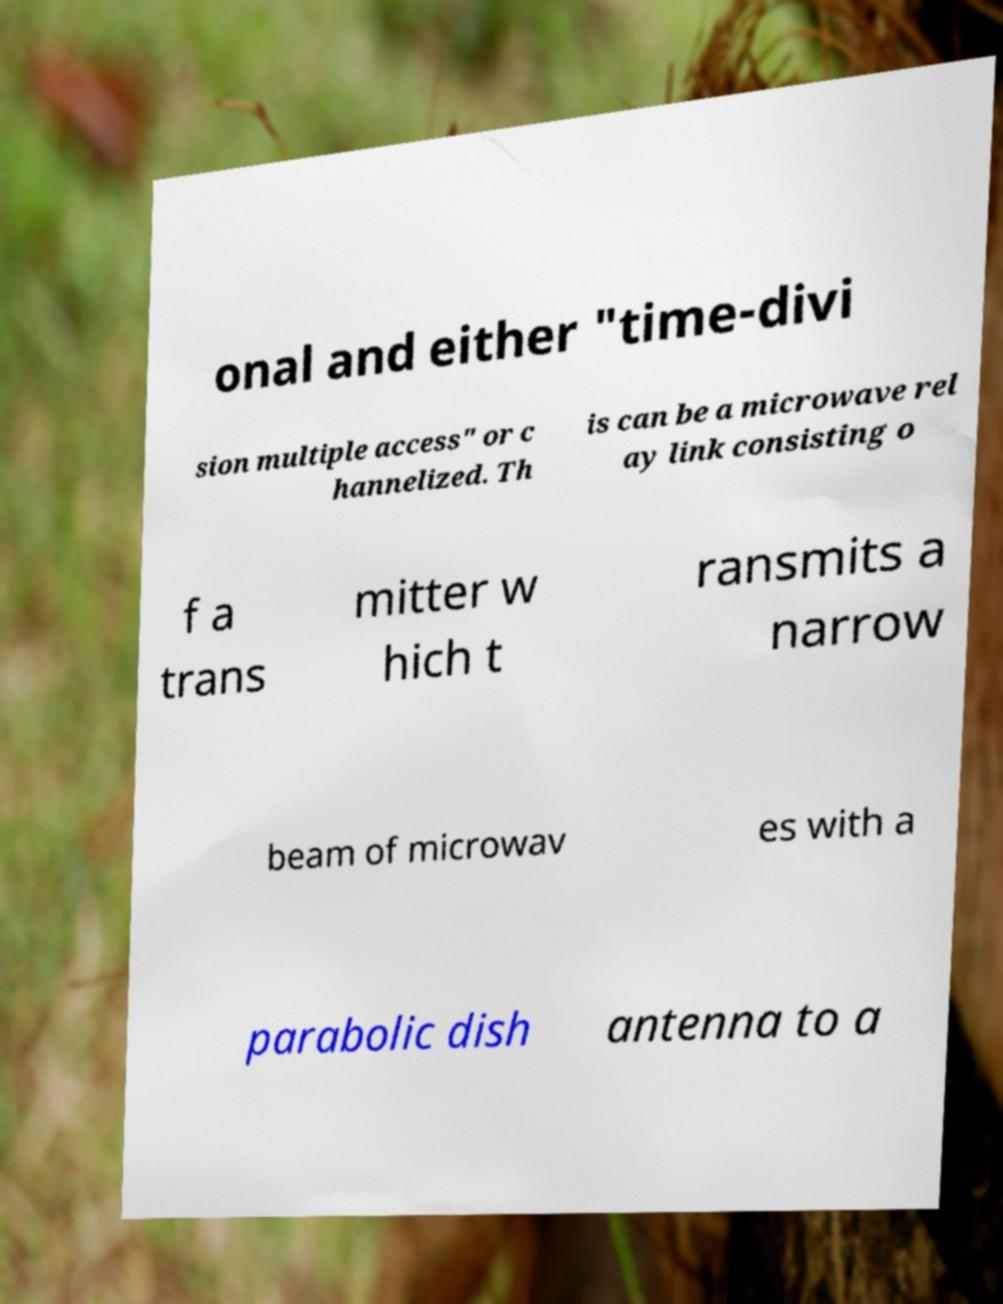There's text embedded in this image that I need extracted. Can you transcribe it verbatim? onal and either "time-divi sion multiple access" or c hannelized. Th is can be a microwave rel ay link consisting o f a trans mitter w hich t ransmits a narrow beam of microwav es with a parabolic dish antenna to a 